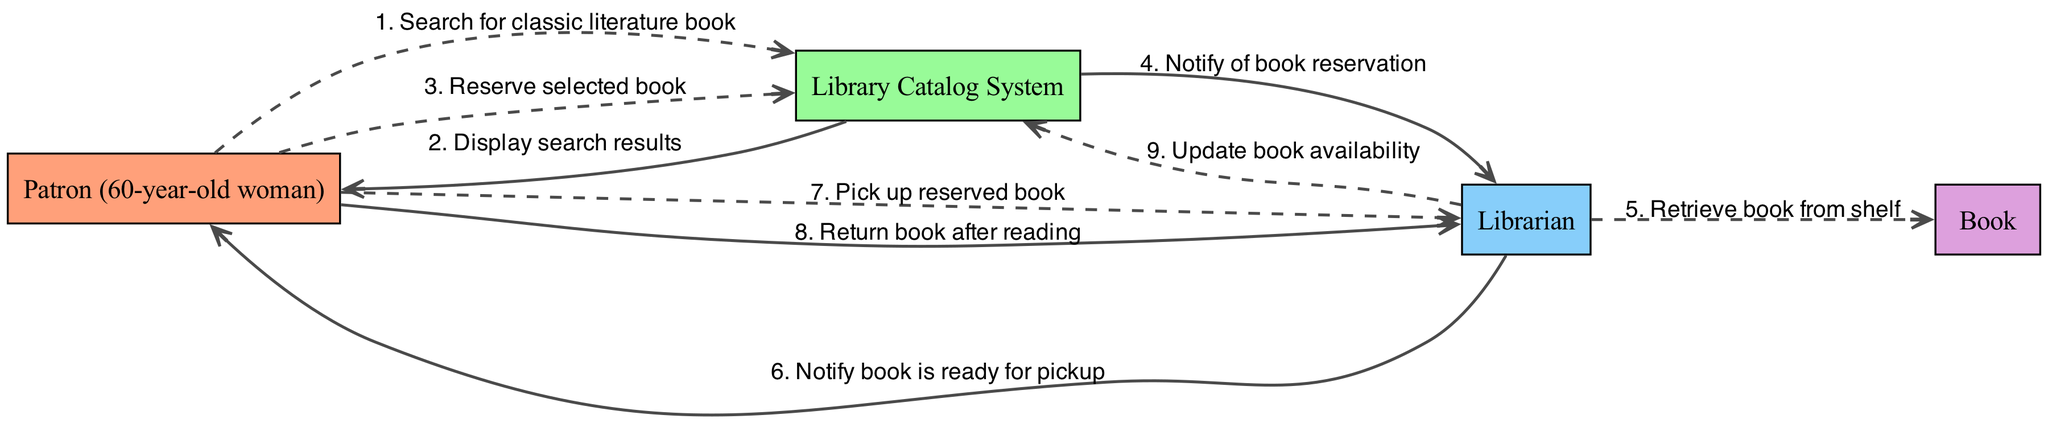What is the first action taken by the patron? The first action taken by the patron is to search for a classic literature book, as indicated by the first message in the diagram.
Answer: Search for classic literature book How many actors are involved in the diagram? The diagram features four actors: the Patron, Library Catalog System, Librarian, and Book, which can be counted from the list of actors.
Answer: Four What message does the librarian send after receiving the reservation notification? The librarian notifies the patron that the book is ready for pickup, which follows the action of notifying the librarian of the reservation.
Answer: Notify book is ready for pickup What action occurs immediately after the reservation is made? After the patron reserves the selected book, the library catalog system notifies the librarian of the book reservation, showing the sequence of actions in the process.
Answer: Notify of book reservation How many messages do not involve the patron? There are three messages that do not involve the patron: the library catalog system notifying the librarian, the librarian retrieving the book from the shelf, and the librarian updating the book’s availability.
Answer: Three What happens to the book after the patron picks it up? After the patron picks up the reserved book, the next action is the patron returning the book after reading, which indicates the circular nature of the borrowing process.
Answer: Return book after reading What is the final action taken in the flow of the borrowing process? The final action in the sequence is the librarian updating the book availability after the patron returns the book, marking the end of the borrowing cycle.
Answer: Update book availability Which actor is responsible for retrieving the book from the shelf? The librarian is responsible for retrieving the book from the shelf, as indicated in the flow of actions following the notification of the reservation.
Answer: Librarian What type of messages does the librarian send regarding book availability? The librarian sends a message to notify the patron that the book is ready for pickup and also updates the library catalog system after the book is returned, indicating actions related to book availability.
Answer: Notify and Update 